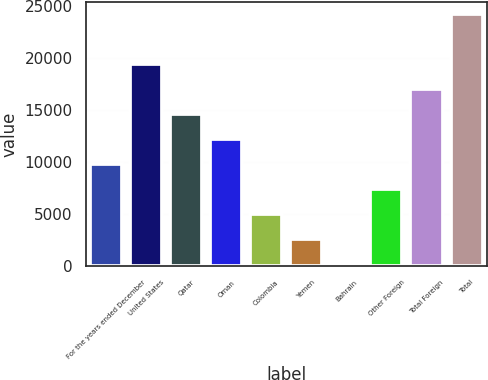Convert chart to OTSL. <chart><loc_0><loc_0><loc_500><loc_500><bar_chart><fcel>For the years ended December<fcel>United States<fcel>Qatar<fcel>Oman<fcel>Colombia<fcel>Yemen<fcel>Bahrain<fcel>Other Foreign<fcel>Total Foreign<fcel>Total<nl><fcel>9797.8<fcel>19380.6<fcel>14589.2<fcel>12193.5<fcel>5006.4<fcel>2610.7<fcel>215<fcel>7402.1<fcel>16984.9<fcel>24172<nl></chart> 